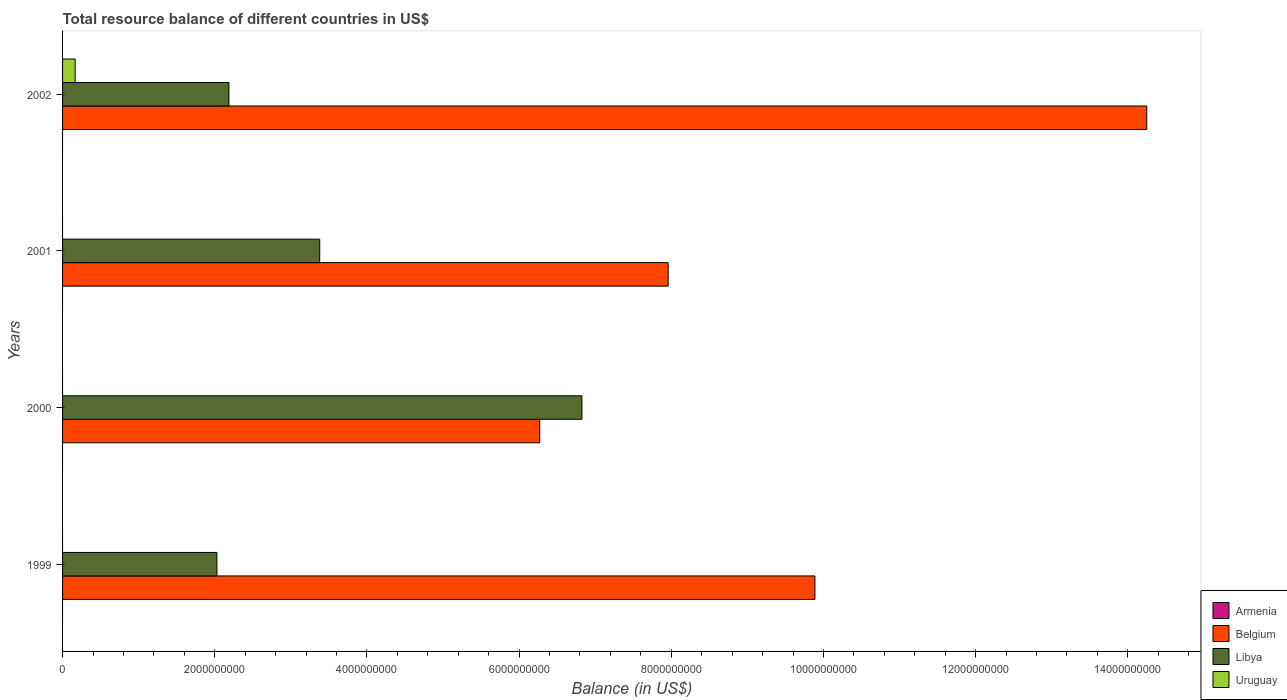How many bars are there on the 4th tick from the top?
Offer a very short reply. 2. What is the total resource balance in Belgium in 1999?
Offer a very short reply. 9.89e+09. Across all years, what is the maximum total resource balance in Uruguay?
Give a very brief answer. 1.65e+08. Across all years, what is the minimum total resource balance in Belgium?
Make the answer very short. 6.27e+09. What is the total total resource balance in Libya in the graph?
Your answer should be compact. 1.44e+1. What is the difference between the total resource balance in Libya in 2000 and that in 2001?
Provide a short and direct response. 3.45e+09. What is the difference between the total resource balance in Belgium in 2000 and the total resource balance in Uruguay in 1999?
Your answer should be very brief. 6.27e+09. What is the average total resource balance in Armenia per year?
Your answer should be very brief. 0. In the year 2001, what is the difference between the total resource balance in Belgium and total resource balance in Libya?
Keep it short and to the point. 4.58e+09. What is the ratio of the total resource balance in Belgium in 1999 to that in 2000?
Ensure brevity in your answer.  1.58. What is the difference between the highest and the second highest total resource balance in Libya?
Ensure brevity in your answer.  3.45e+09. What is the difference between the highest and the lowest total resource balance in Belgium?
Provide a succinct answer. 7.98e+09. Is the sum of the total resource balance in Belgium in 2000 and 2002 greater than the maximum total resource balance in Armenia across all years?
Your answer should be very brief. Yes. Is it the case that in every year, the sum of the total resource balance in Uruguay and total resource balance in Armenia is greater than the total resource balance in Belgium?
Ensure brevity in your answer.  No. How many bars are there?
Offer a very short reply. 9. Are all the bars in the graph horizontal?
Offer a very short reply. Yes. What is the difference between two consecutive major ticks on the X-axis?
Keep it short and to the point. 2.00e+09. Does the graph contain any zero values?
Provide a succinct answer. Yes. Where does the legend appear in the graph?
Your answer should be very brief. Bottom right. How are the legend labels stacked?
Offer a terse response. Vertical. What is the title of the graph?
Provide a succinct answer. Total resource balance of different countries in US$. What is the label or title of the X-axis?
Offer a very short reply. Balance (in US$). What is the label or title of the Y-axis?
Give a very brief answer. Years. What is the Balance (in US$) of Belgium in 1999?
Offer a very short reply. 9.89e+09. What is the Balance (in US$) of Libya in 1999?
Give a very brief answer. 2.03e+09. What is the Balance (in US$) in Belgium in 2000?
Your answer should be very brief. 6.27e+09. What is the Balance (in US$) in Libya in 2000?
Provide a short and direct response. 6.83e+09. What is the Balance (in US$) in Belgium in 2001?
Make the answer very short. 7.96e+09. What is the Balance (in US$) in Libya in 2001?
Provide a short and direct response. 3.38e+09. What is the Balance (in US$) in Belgium in 2002?
Ensure brevity in your answer.  1.42e+1. What is the Balance (in US$) in Libya in 2002?
Offer a very short reply. 2.19e+09. What is the Balance (in US$) of Uruguay in 2002?
Offer a very short reply. 1.65e+08. Across all years, what is the maximum Balance (in US$) of Belgium?
Offer a very short reply. 1.42e+1. Across all years, what is the maximum Balance (in US$) in Libya?
Ensure brevity in your answer.  6.83e+09. Across all years, what is the maximum Balance (in US$) of Uruguay?
Make the answer very short. 1.65e+08. Across all years, what is the minimum Balance (in US$) of Belgium?
Offer a very short reply. 6.27e+09. Across all years, what is the minimum Balance (in US$) in Libya?
Offer a very short reply. 2.03e+09. What is the total Balance (in US$) in Armenia in the graph?
Make the answer very short. 0. What is the total Balance (in US$) of Belgium in the graph?
Ensure brevity in your answer.  3.84e+1. What is the total Balance (in US$) of Libya in the graph?
Provide a short and direct response. 1.44e+1. What is the total Balance (in US$) in Uruguay in the graph?
Ensure brevity in your answer.  1.65e+08. What is the difference between the Balance (in US$) in Belgium in 1999 and that in 2000?
Offer a very short reply. 3.62e+09. What is the difference between the Balance (in US$) in Libya in 1999 and that in 2000?
Your answer should be very brief. -4.80e+09. What is the difference between the Balance (in US$) of Belgium in 1999 and that in 2001?
Ensure brevity in your answer.  1.93e+09. What is the difference between the Balance (in US$) of Libya in 1999 and that in 2001?
Your response must be concise. -1.35e+09. What is the difference between the Balance (in US$) of Belgium in 1999 and that in 2002?
Offer a very short reply. -4.36e+09. What is the difference between the Balance (in US$) of Libya in 1999 and that in 2002?
Your response must be concise. -1.58e+08. What is the difference between the Balance (in US$) of Belgium in 2000 and that in 2001?
Keep it short and to the point. -1.69e+09. What is the difference between the Balance (in US$) in Libya in 2000 and that in 2001?
Give a very brief answer. 3.45e+09. What is the difference between the Balance (in US$) in Belgium in 2000 and that in 2002?
Make the answer very short. -7.98e+09. What is the difference between the Balance (in US$) of Libya in 2000 and that in 2002?
Ensure brevity in your answer.  4.64e+09. What is the difference between the Balance (in US$) of Belgium in 2001 and that in 2002?
Your answer should be very brief. -6.29e+09. What is the difference between the Balance (in US$) in Libya in 2001 and that in 2002?
Ensure brevity in your answer.  1.19e+09. What is the difference between the Balance (in US$) in Belgium in 1999 and the Balance (in US$) in Libya in 2000?
Provide a short and direct response. 3.06e+09. What is the difference between the Balance (in US$) in Belgium in 1999 and the Balance (in US$) in Libya in 2001?
Ensure brevity in your answer.  6.51e+09. What is the difference between the Balance (in US$) in Belgium in 1999 and the Balance (in US$) in Libya in 2002?
Offer a terse response. 7.70e+09. What is the difference between the Balance (in US$) of Belgium in 1999 and the Balance (in US$) of Uruguay in 2002?
Keep it short and to the point. 9.72e+09. What is the difference between the Balance (in US$) in Libya in 1999 and the Balance (in US$) in Uruguay in 2002?
Provide a short and direct response. 1.86e+09. What is the difference between the Balance (in US$) of Belgium in 2000 and the Balance (in US$) of Libya in 2001?
Keep it short and to the point. 2.89e+09. What is the difference between the Balance (in US$) in Belgium in 2000 and the Balance (in US$) in Libya in 2002?
Your response must be concise. 4.08e+09. What is the difference between the Balance (in US$) in Belgium in 2000 and the Balance (in US$) in Uruguay in 2002?
Make the answer very short. 6.11e+09. What is the difference between the Balance (in US$) in Libya in 2000 and the Balance (in US$) in Uruguay in 2002?
Provide a short and direct response. 6.66e+09. What is the difference between the Balance (in US$) of Belgium in 2001 and the Balance (in US$) of Libya in 2002?
Your answer should be compact. 5.77e+09. What is the difference between the Balance (in US$) in Belgium in 2001 and the Balance (in US$) in Uruguay in 2002?
Offer a terse response. 7.79e+09. What is the difference between the Balance (in US$) in Libya in 2001 and the Balance (in US$) in Uruguay in 2002?
Offer a terse response. 3.21e+09. What is the average Balance (in US$) of Belgium per year?
Ensure brevity in your answer.  9.59e+09. What is the average Balance (in US$) of Libya per year?
Your response must be concise. 3.61e+09. What is the average Balance (in US$) in Uruguay per year?
Your response must be concise. 4.13e+07. In the year 1999, what is the difference between the Balance (in US$) of Belgium and Balance (in US$) of Libya?
Your answer should be very brief. 7.86e+09. In the year 2000, what is the difference between the Balance (in US$) in Belgium and Balance (in US$) in Libya?
Ensure brevity in your answer.  -5.54e+08. In the year 2001, what is the difference between the Balance (in US$) of Belgium and Balance (in US$) of Libya?
Give a very brief answer. 4.58e+09. In the year 2002, what is the difference between the Balance (in US$) in Belgium and Balance (in US$) in Libya?
Make the answer very short. 1.21e+1. In the year 2002, what is the difference between the Balance (in US$) of Belgium and Balance (in US$) of Uruguay?
Give a very brief answer. 1.41e+1. In the year 2002, what is the difference between the Balance (in US$) of Libya and Balance (in US$) of Uruguay?
Provide a short and direct response. 2.02e+09. What is the ratio of the Balance (in US$) in Belgium in 1999 to that in 2000?
Offer a very short reply. 1.58. What is the ratio of the Balance (in US$) of Libya in 1999 to that in 2000?
Your answer should be very brief. 0.3. What is the ratio of the Balance (in US$) in Belgium in 1999 to that in 2001?
Provide a succinct answer. 1.24. What is the ratio of the Balance (in US$) in Libya in 1999 to that in 2001?
Offer a terse response. 0.6. What is the ratio of the Balance (in US$) in Belgium in 1999 to that in 2002?
Offer a terse response. 0.69. What is the ratio of the Balance (in US$) in Libya in 1999 to that in 2002?
Provide a succinct answer. 0.93. What is the ratio of the Balance (in US$) in Belgium in 2000 to that in 2001?
Offer a terse response. 0.79. What is the ratio of the Balance (in US$) of Libya in 2000 to that in 2001?
Provide a succinct answer. 2.02. What is the ratio of the Balance (in US$) in Belgium in 2000 to that in 2002?
Offer a very short reply. 0.44. What is the ratio of the Balance (in US$) in Libya in 2000 to that in 2002?
Your answer should be compact. 3.12. What is the ratio of the Balance (in US$) of Belgium in 2001 to that in 2002?
Offer a terse response. 0.56. What is the ratio of the Balance (in US$) of Libya in 2001 to that in 2002?
Your answer should be compact. 1.55. What is the difference between the highest and the second highest Balance (in US$) in Belgium?
Your answer should be compact. 4.36e+09. What is the difference between the highest and the second highest Balance (in US$) of Libya?
Offer a terse response. 3.45e+09. What is the difference between the highest and the lowest Balance (in US$) of Belgium?
Your response must be concise. 7.98e+09. What is the difference between the highest and the lowest Balance (in US$) in Libya?
Offer a terse response. 4.80e+09. What is the difference between the highest and the lowest Balance (in US$) in Uruguay?
Offer a terse response. 1.65e+08. 